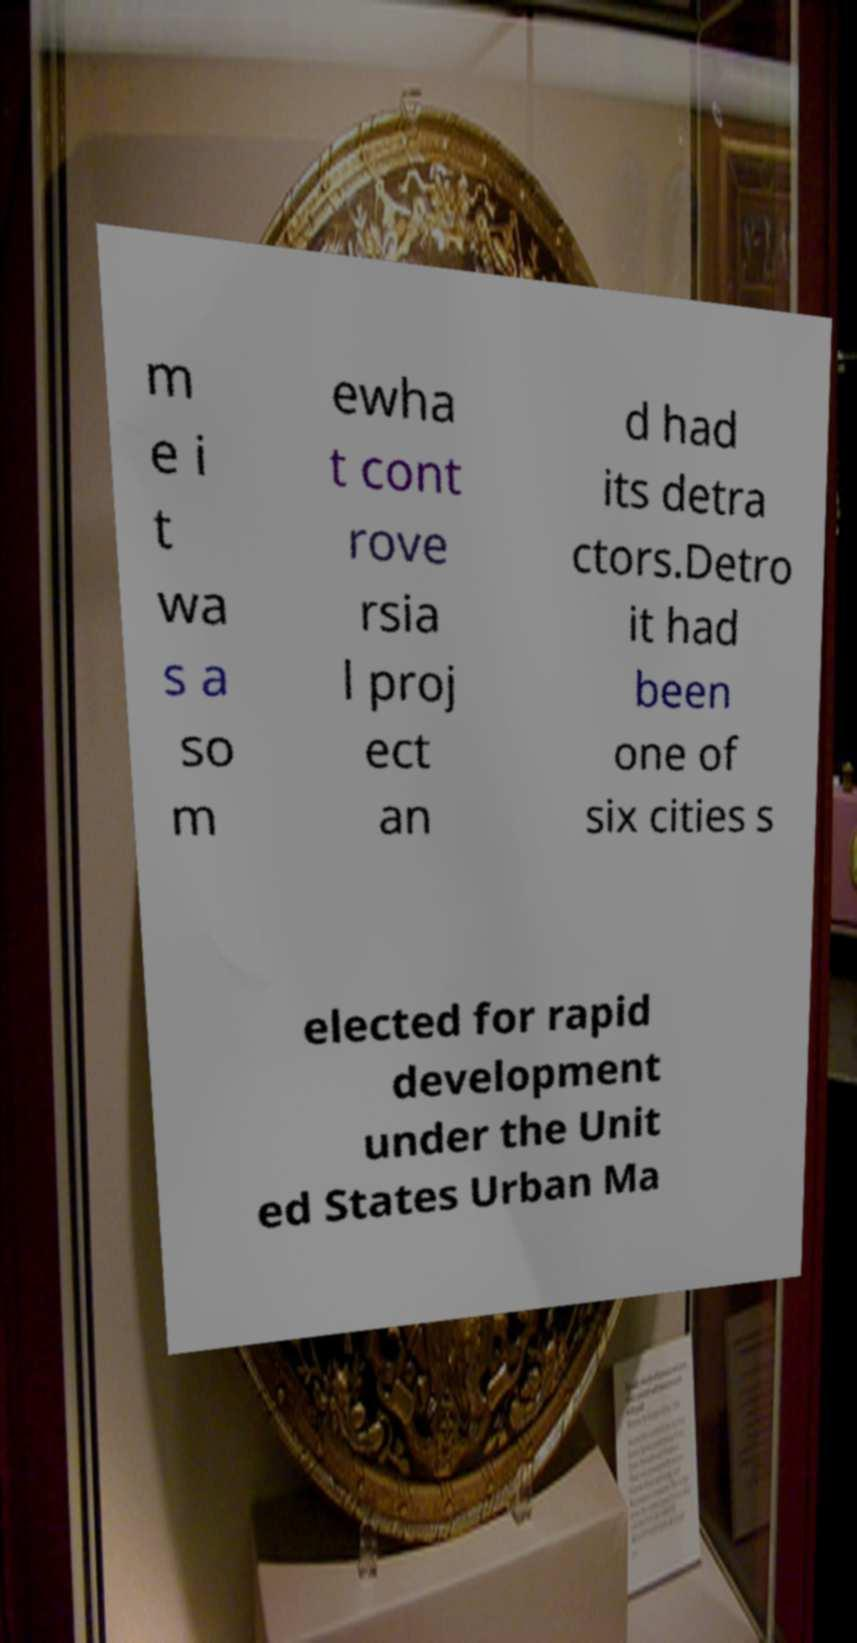Please identify and transcribe the text found in this image. m e i t wa s a so m ewha t cont rove rsia l proj ect an d had its detra ctors.Detro it had been one of six cities s elected for rapid development under the Unit ed States Urban Ma 